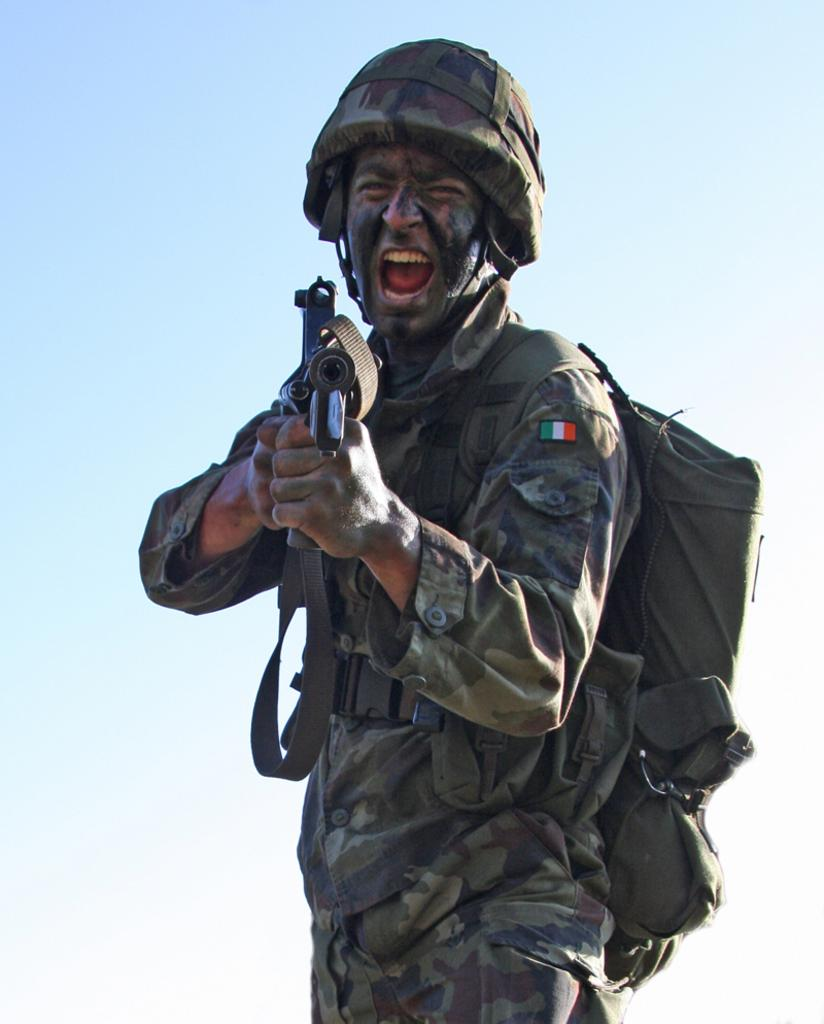What is the main subject of the image? There is a person in the image. What type of clothing is the person wearing? The person is wearing an army uniform. What additional items can be seen on the person? The person has a badge, a bag, a helmet, and is holding a gun. What type of bubble is the person blowing in the image? There is no bubble present in the image. What kind of doll is the person holding in the image? There is no doll present in the image. 